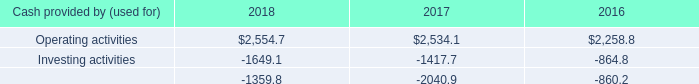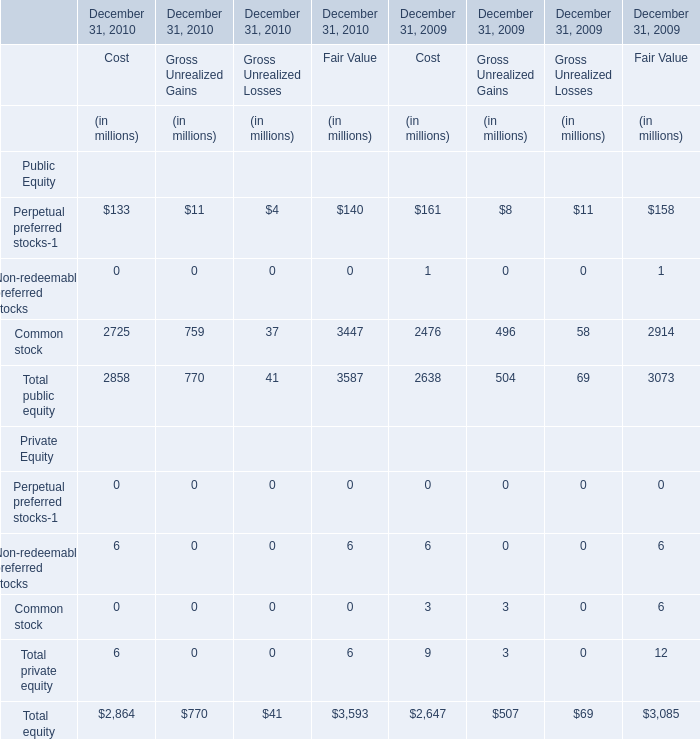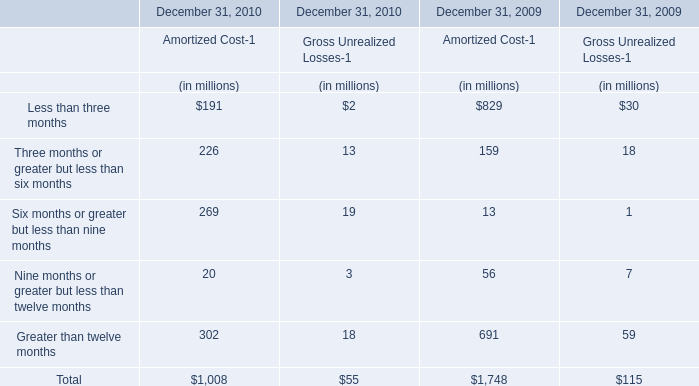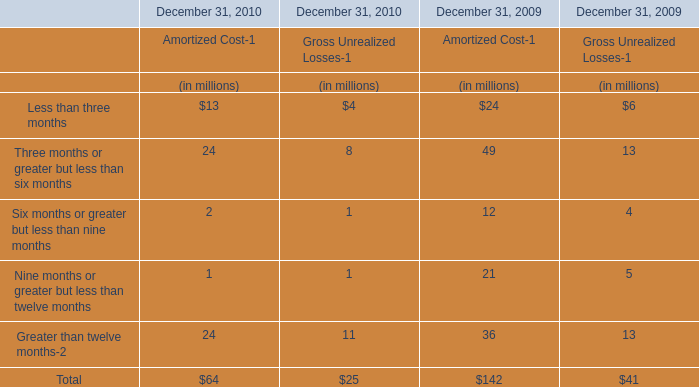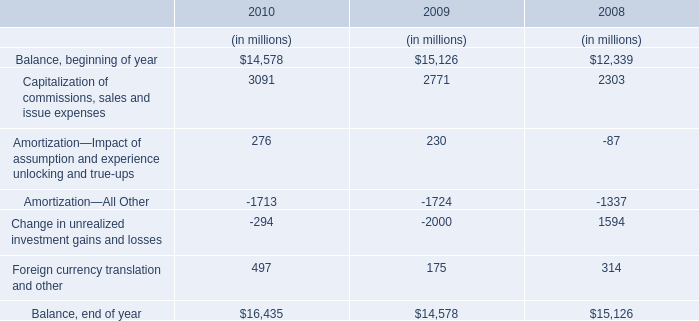What is the difference between the greatest Amortized Cost-1 in 2009 and 2010？ (in million) 
Computations: (302 - 829)
Answer: -527.0. 